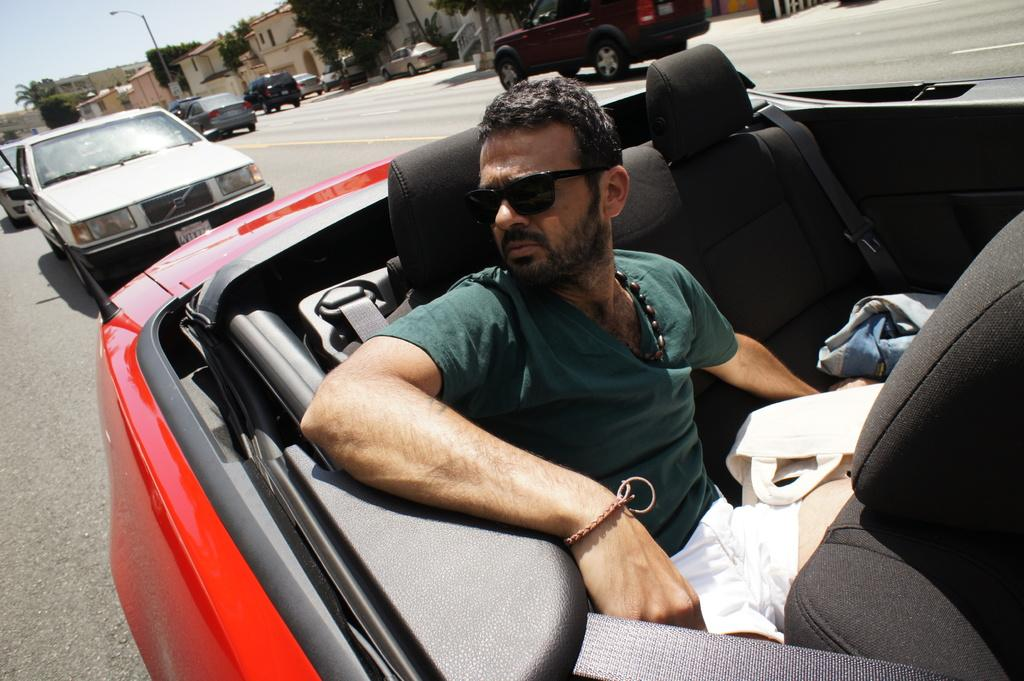What is the man in the image doing? The man is sitting in a car. Where is the car located? The car is on the road. What can be seen in the background of the image? There are trees, other cars, a pole, and the sky visible in the background. How many cows are grazing in the background of the image? There are no cows present in the image; the background features trees, other cars, a pole, and the sky. 